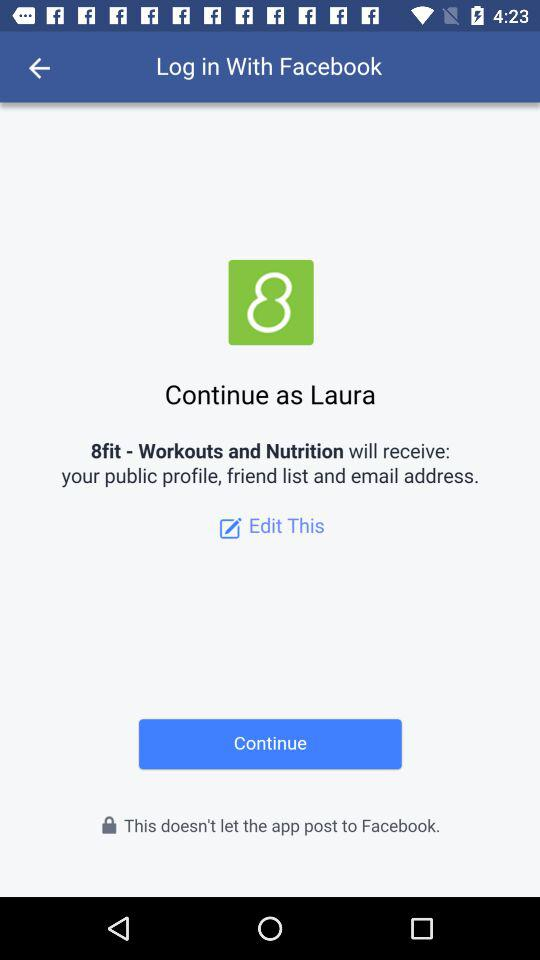What application will receive the public profile and email address? The application "8fit - Workouts and Nutrition" will receive the public profile and email address. 